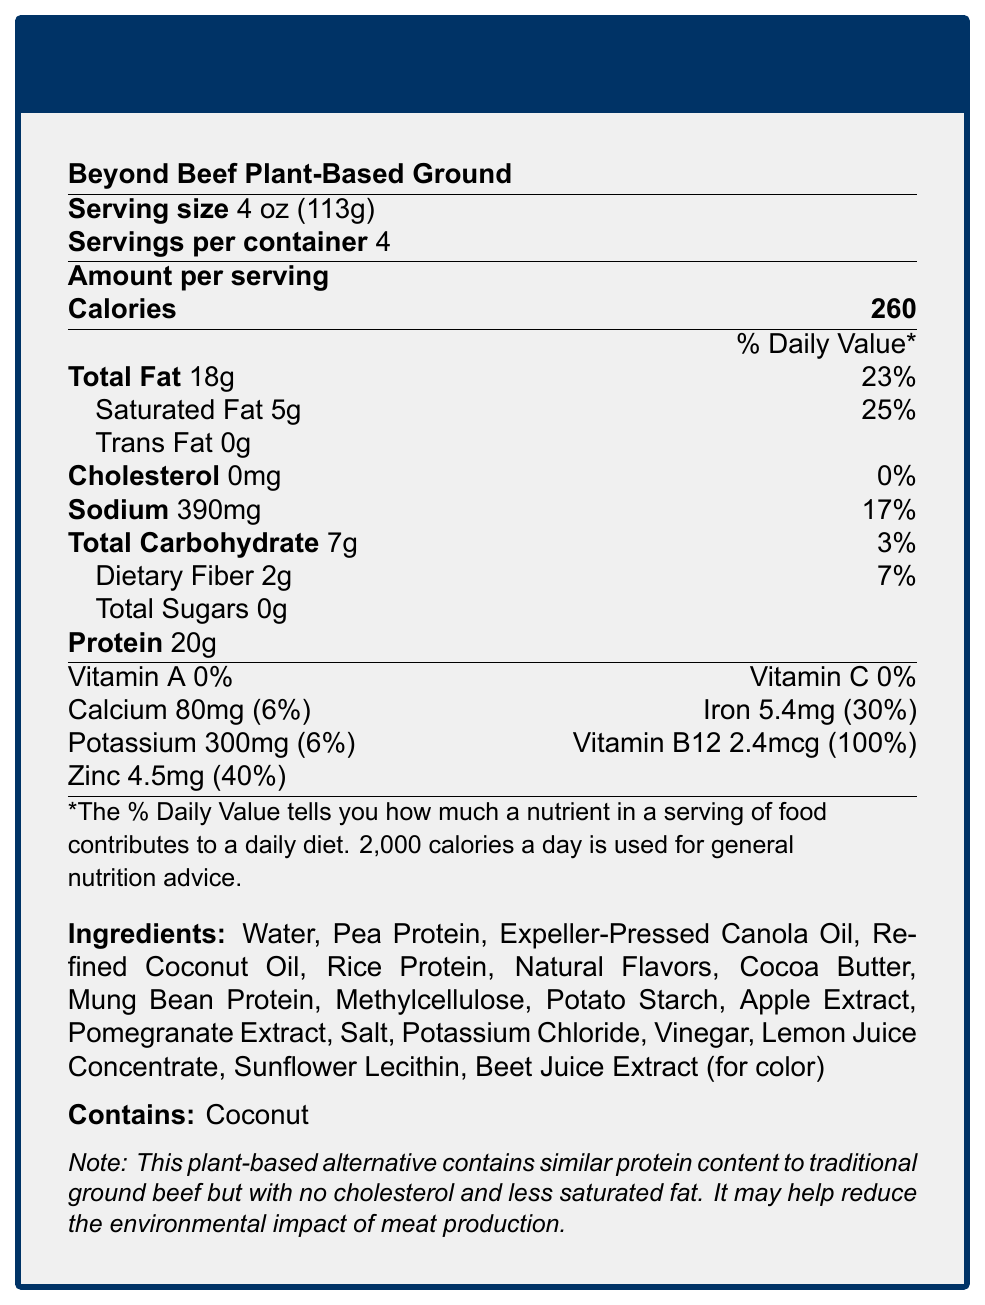what is the serving size? The serving size is clearly mentioned at the top of the document.
Answer: 4 oz (113g) how many calories are in one serving? The amount of calories per serving is specified as 260.
Answer: 260 what percentage of the daily value for saturated fat does one serving contain? The daily value percentage for saturated fat is listed as 25%.
Answer: 25% which vitamin is present at 100% of the daily value? The daily value for Vitamin B12 is shown as 100%.
Answer: Vitamin B12 what allergen is contained in this product? The document states that the product contains coconut in the allergen information section.
Answer: Coconut how much protein does one serving contain? The amount of protein per serving is listed as 20 grams.
Answer: 20g does this product contain any cholesterol? The document lists the cholesterol content as 0mg.
Answer: No which mineral has a daily value of 30% per serving? The daily value for iron is 30%, as shown in the nutritional information.
Answer: Iron what is the primary ingredient in this product? The first ingredient listed is water, which indicates it is the primary ingredient.
Answer: Water true or false: this product contains more sodium than potassium per serving. The document states it contains 390mg of sodium and 300mg of potassium, so it contains more sodium.
Answer: True which of the following are ingredients in the product? A. Soy Protein B. Mung Bean Protein C. Wheat Gluten The document lists mung bean protein as one of the ingredients.
Answer: B. Mung Bean Protein what is the total carbohydrate content per serving? The total carbohydrate content is listed as 7 grams per serving.
Answer: 7g how many servings are in one container of this product? The number of servings per container is stated to be 4.
Answer: 4 what is the economic impact of plant-based protein market growth according to the document? The document mentions that the plant-based protein market growth could impact traditional agricultural sectors, necessitating possible policy adjustments.
Answer: May affect traditional agricultural sectors and may require policy adjustments to balance economic interests describe the overall nutritional profile of this product. The nutritional profile includes detailed information on the calories, fats, cholesterol, sodium, carbohydrates, protein, vitamins, and minerals per serving, as well as noting the allergen.
Answer: This product has 260 calories per serving, with 18g of total fat, 5g of saturated fat, 0mg of cholesterol, 390mg of sodium, 7g of total carbohydrates, 2g of dietary fiber, 20g of protein, and various vitamins and minerals, notably 100% daily value of Vitamin B12 and 40% daily value of Zinc. It is a plant-based alternative similar in protein content to traditional ground beef but with no cholesterol and less saturated fat. It contains coconut as an allergen. does this product contain any Vitamin D? There is no mention of Vitamin D content in the provided document.
Answer: Not enough information 